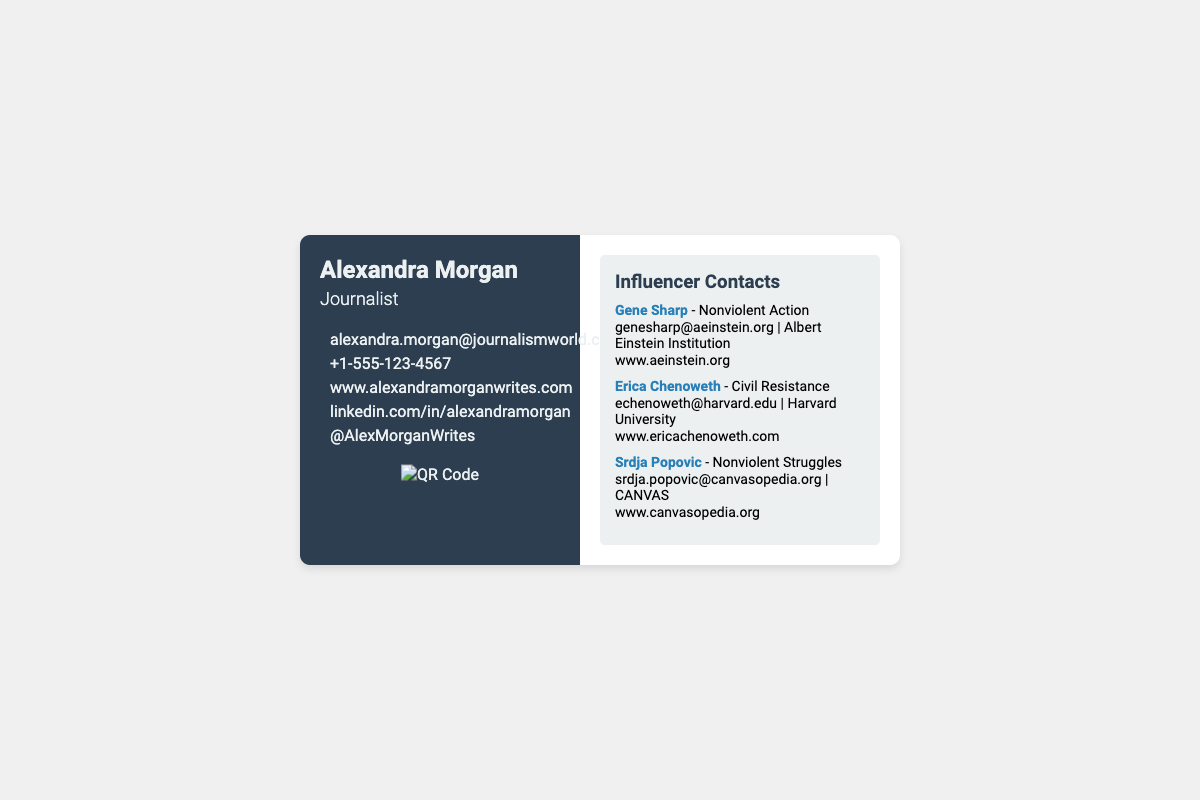What is the full name of the journalist? The full name of the journalist is mentioned at the top of the card.
Answer: Alexandra Morgan What is the email address of Alexandra Morgan? The email address can be found in the contact information section.
Answer: alexandra.morgan@journalismworld.com What is the phone number provided? The phone number is listed along with the other contact details.
Answer: +1-555-123-4567 Which university is Erica Chenoweth associated with? The university affiliation for Erica Chenoweth is provided in her contact information.
Answer: Harvard University What is the main focus area of Srdja Popovic? The focus area of Srdja Popovic is noted next to his name in the contact list.
Answer: Nonviolent Struggles How many influencers are listed in the document? The number of influencers can be determined by counting the contacts in the portfolio section.
Answer: 3 What color is the left section of the business card? The background color of the left section is described within the style section of the card.
Answer: Dark blue What type of code is included in the business card? The type of code included on the business card is identified in the QR code section.
Answer: QR Code What is the website URL for Alexandra Morgan? The website URL is listed under the contact information.
Answer: www.alexandramorganwrites.com 